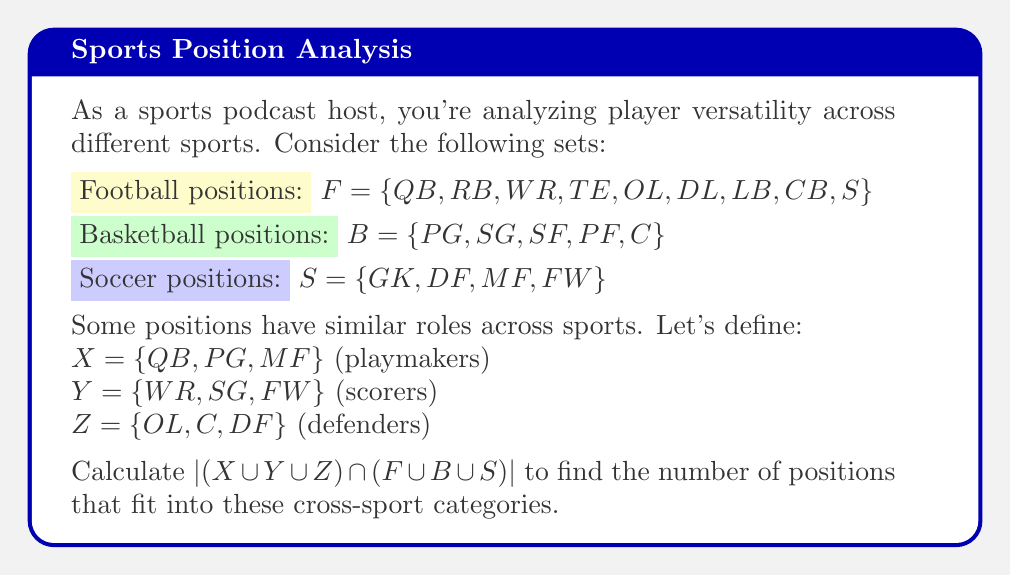Give your solution to this math problem. Let's approach this step-by-step:

1) First, let's find $X \cup Y \cup Z$:
   $X \cup Y \cup Z = \{QB, PG, MF, WR, SG, FW, OL, C, DF\}$

2) Next, let's find $F \cup B \cup S$:
   $F \cup B \cup S = \{QB, RB, WR, TE, OL, DL, LB, CB, S, PG, SG, SF, PF, C, GK, DF, MF, FW\}$

3) Now, we need to find the intersection of these two sets:
   $(X \cup Y \cup Z) \cap (F \cup B \cup S)$
   = $\{QB, PG, MF, WR, SG, FW, OL, C, DF\}$

4) The question asks for the cardinality (number of elements) of this intersection.
   $|(X \cup Y \cup Z) \cap (F \cup B \cup S)| = 9$

Each element in this set represents a position that fits into one of the cross-sport categories (playmakers, scorers, or defenders) and is also a valid position in at least one of the sports.
Answer: 9 